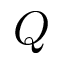<formula> <loc_0><loc_0><loc_500><loc_500>Q</formula> 